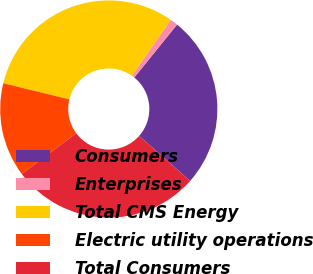Convert chart. <chart><loc_0><loc_0><loc_500><loc_500><pie_chart><fcel>Consumers<fcel>Enterprises<fcel>Total CMS Energy<fcel>Electric utility operations<fcel>Total Consumers<nl><fcel>25.7%<fcel>1.17%<fcel>30.84%<fcel>14.02%<fcel>28.27%<nl></chart> 